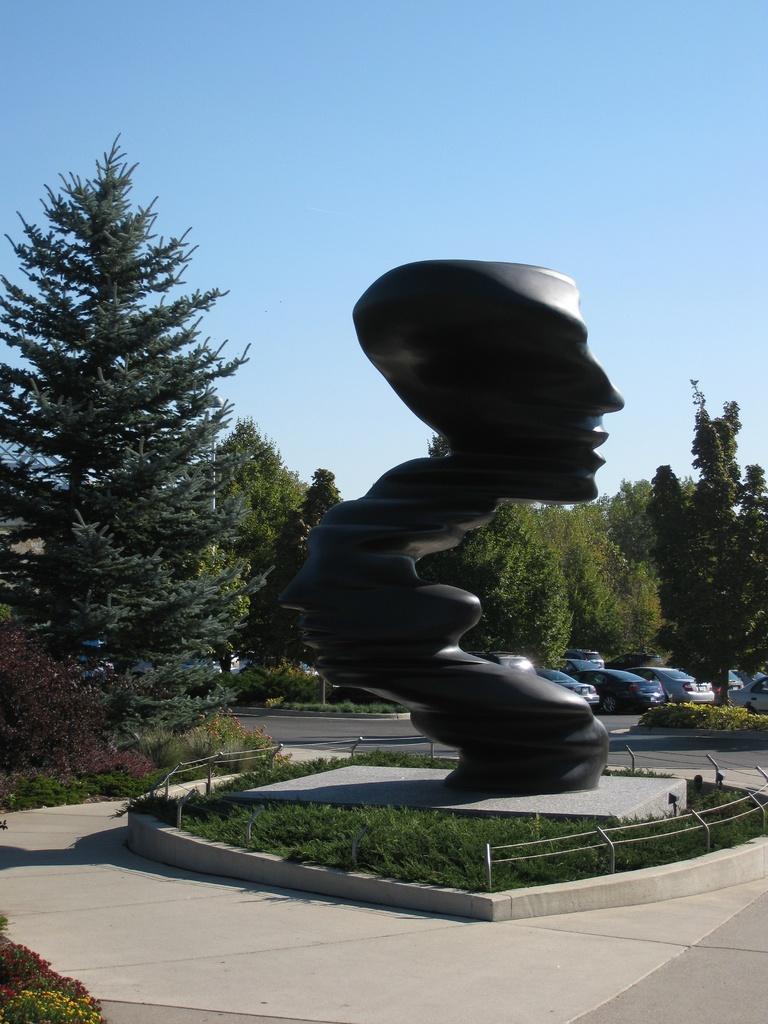In one or two sentences, can you explain what this image depicts? There is a statue which is black in color and there is a fence around it and there are trees and vehicles in the background. 